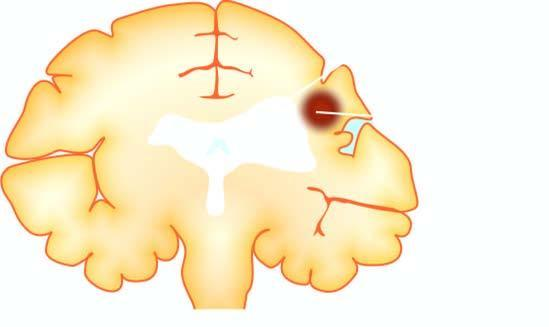what is there of scarred area with ipsilateral ventricular dilatation?
Answer the question using a single word or phrase. Shrinkage 